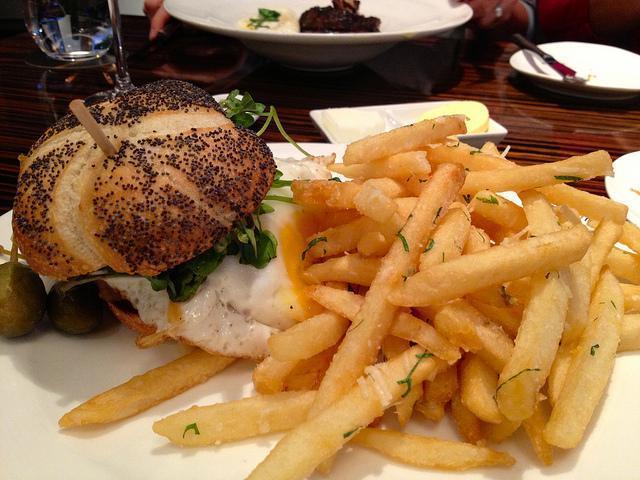Does the caption "The person is above the sandwich." correctly depict the image?
Answer yes or no. No. 